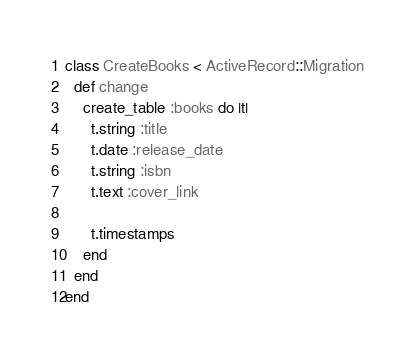Convert code to text. <code><loc_0><loc_0><loc_500><loc_500><_Ruby_>class CreateBooks < ActiveRecord::Migration
  def change
    create_table :books do |t|
      t.string :title
      t.date :release_date
      t.string :isbn
      t.text :cover_link

      t.timestamps
    end
  end
end
</code> 